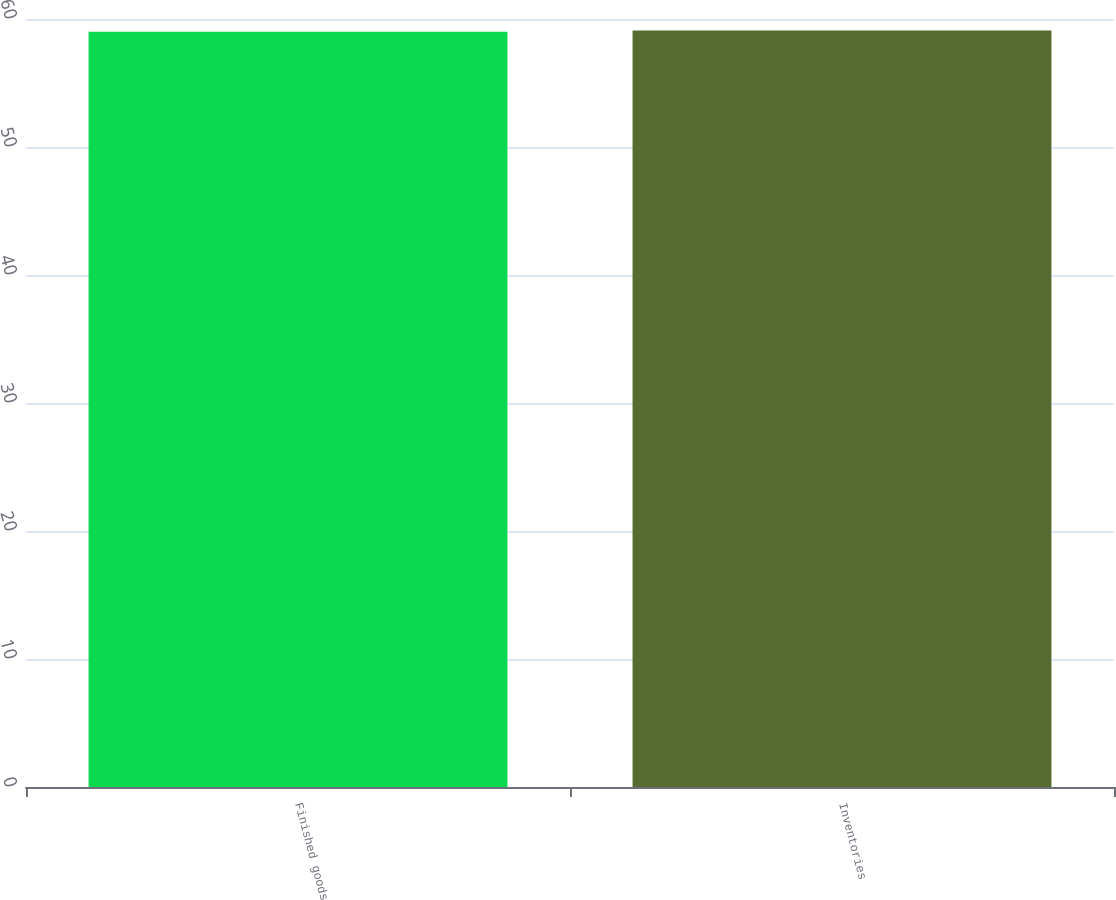Convert chart. <chart><loc_0><loc_0><loc_500><loc_500><bar_chart><fcel>Finished goods<fcel>Inventories<nl><fcel>59<fcel>59.1<nl></chart> 